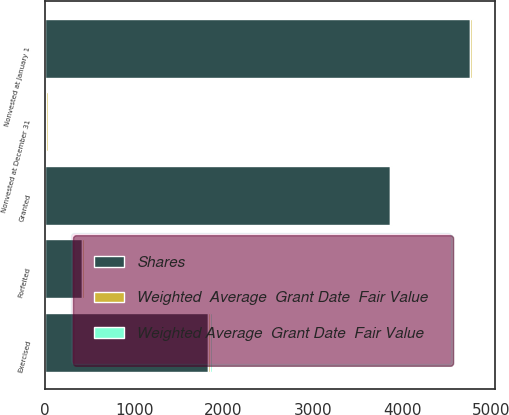Convert chart. <chart><loc_0><loc_0><loc_500><loc_500><stacked_bar_chart><ecel><fcel>Nonvested at January 1<fcel>Granted<fcel>Exercised<fcel>Forfeited<fcel>Nonvested at December 31<nl><fcel>Shares<fcel>4764<fcel>3863<fcel>1826<fcel>422<fcel>17.16<nl><fcel>Weighted Average  Grant Date  Fair Value<fcel>15.95<fcel>14.33<fcel>18.37<fcel>15.35<fcel>14.32<nl><fcel>Weighted  Average  Grant Date  Fair Value<fcel>18.89<fcel>13.19<fcel>22.52<fcel>15.34<fcel>15.95<nl></chart> 